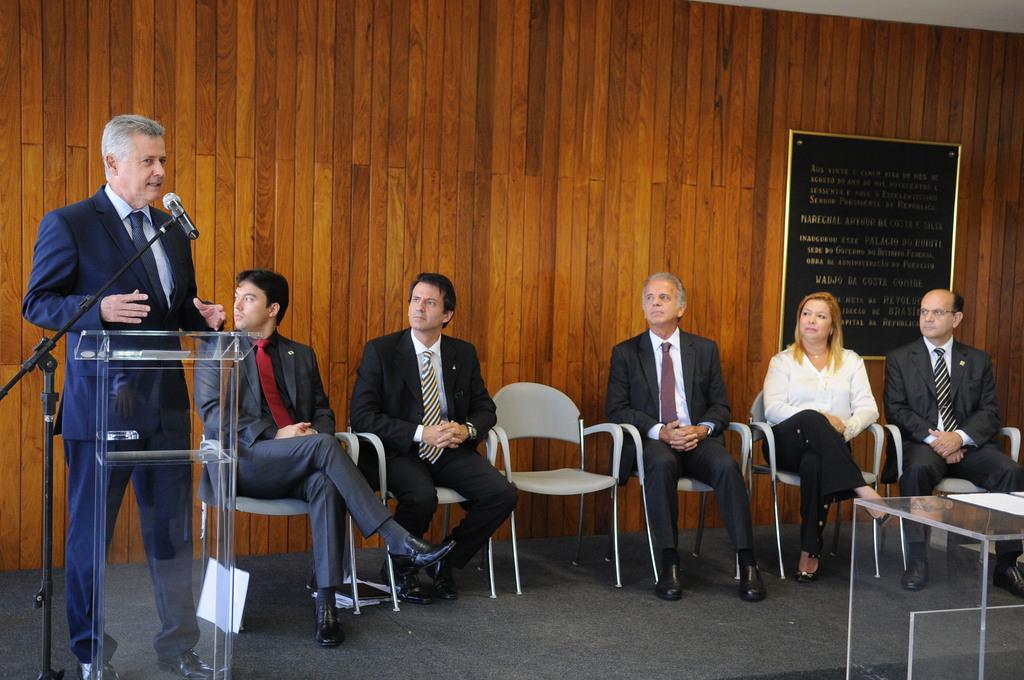Who is the main subject in the image? There is a man in the image. What is the man doing in the image? The man is talking on a mic. Where is the man located in the image? The man is on the left side of the image. Can you describe the setting of the image? The setting appears to be a conference hall. How many cats are visible in the image? There are no cats present in the image. What type of lumber is being used to construct the stage in the image? There is no stage or lumber visible in the image; it is a conference hall setting. 